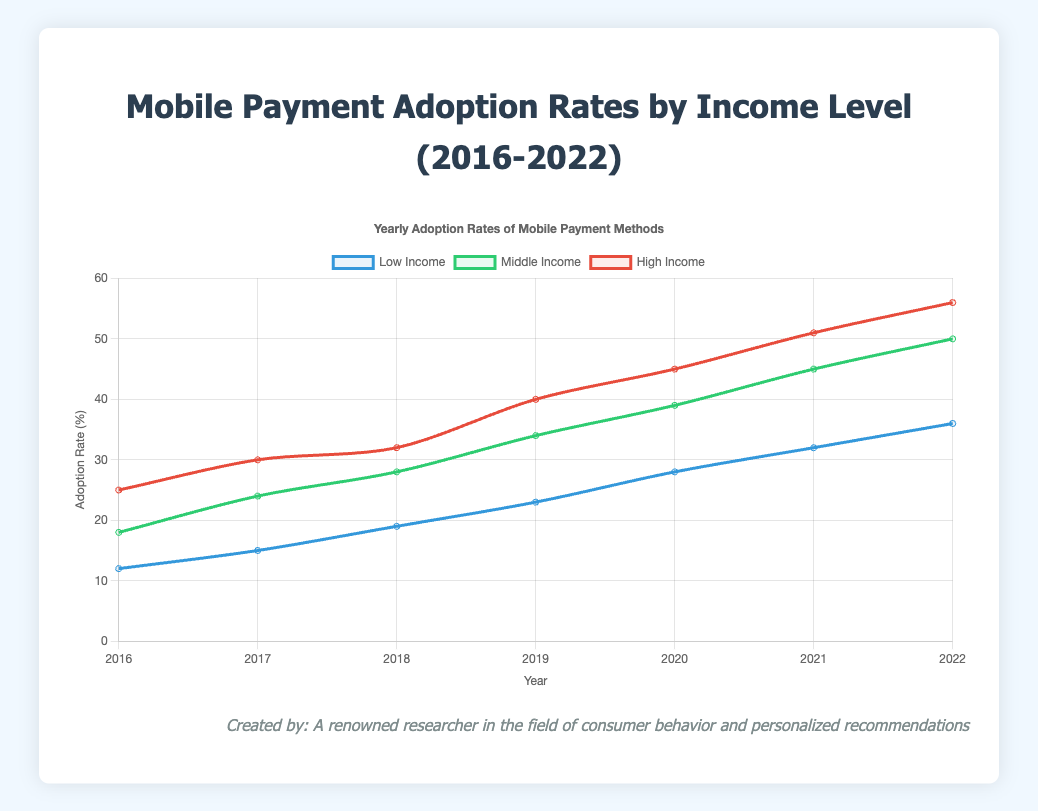what is the adoption rate for middle-income individuals in 2019? Look at the data point corresponding to the middle-income group in the year 2019. The value is shown as 34%
Answer: 34% Which income group saw the most significant increase in adoption rates from 2016 to 2022? Compare the adoption rates of all income groups between 2016 and 2022. The increase for Low Income is 36 - 12 = 24%, for Middle Income is 50 - 18 = 32%, and for High Income is 56 - 25 = 31%. The middle-income group has the highest increase
Answer: Middle Income Which year had the smallest gap in adoption rates between low-income and high-income individuals? Determine the difference in adoption rates each year and find the smallest difference. The differences are: 2016: 25 - 12 = 13%, 2017: 30 - 15 = 15%, 2018: 32 - 19 = 13%, 2019: 40 - 23 = 17%, 2020: 45 - 28 = 17%, 2021: 51 - 32 = 19%, 2022: 56 - 36 = 20%. The smallest gap is seen in 2016 and 2018
Answer: 2016, 2018 What was the average adoption rate for high-income individuals over the seven years? Sum the yearly adoption rates for high-income individuals and divide by the number of years: (25 + 30 + 32 + 40 + 45 + 51 + 56) / 7 = 279 / 7 = 39.86
Answer: 39.86% In which year did the adoption rate for middle-income individuals first exceed 40%? Look at the middle-income adoption rate for each year. 2016: 18%, 2017: 24%, 2018: 28%, 2019: 34%, 2020: 39%, 2021: 45%, 2022: 50%. The rate first exceeds 40% in 2021
Answer: 2021 How does the rate of increase for low-income individuals from 2016 to 2018 compare to that from 2020 to 2022? Calculate the increase for each period: 19 - 12 = 7% (2016 to 2018) and 36 - 28 = 8% (2020 to 2022). The increase is 7% and 8% respectively, showing a greater increase from 2020 to 2022
Answer: Greater increase from 2020 to 2022 How did the adoption rate trend for middle-income individuals from 2018 to 2020 compare with the trend for high-income individuals over the same period? For middle-income individuals, the adoption rate increased from 28% in 2018 to 39% in 2020, a rise of 11%. For high-income individuals, the adoption rate increased from 32% in 2018 to 45% in 2020, a rise of 13%. Both show an upward trend, but high-income has a steeper increase
Answer: Both increased, high-income increased more What is the sum of the adoption rates for low-income individuals in 2017, 2018, and 2019? Add the adoption rates for low-income individuals in these years: 15 + 19 + 23 = 57%
Answer: 57% 